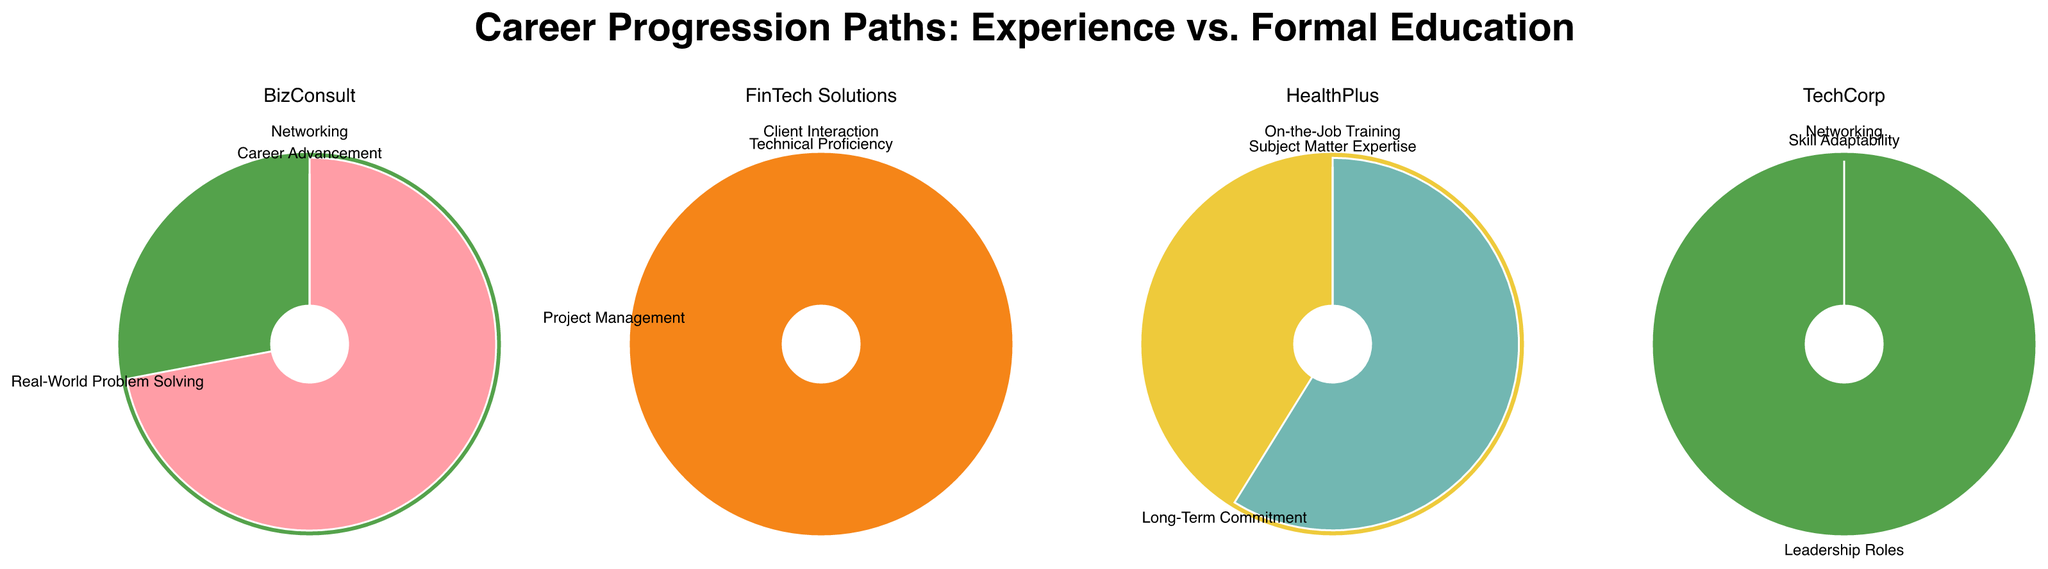What metric does TechCorp value the most in terms of experience? Look at the TechCorp subplot and compare the "Experience" percentage for each metric. "Networking" has the highest value of 90%.
Answer: Networking Which company places the highest value on experience in "Networking"? Compare the "Experience" percentage for "Networking" across all companies. BizConsult values it the most with 95%.
Answer: BizConsult What's the average "Experience" percentage for all metrics in FinTech Solutions? Add the "Experience" percentages for FinTech Solutions (70, 80, 83) and divide by the number of metrics (3). The calculation is (70 + 80 + 83) / 3 = 77.67.
Answer: 77.67 Which metrics in HealthPlus have an "Experience" percentage higher than 80%? HealthPlus has three metrics; check which ones have an "Experience" value above 80%. "On-the-Job Training" (92%) and "Long-Term Commitment" (85%) meet the criteria.
Answer: On-the-Job Training, Long-Term Commitment Between "Technical Proficiency" and "Project Management" in FinTech Solutions, which one has a higher value for formal education? Compare the "Formal Education" values for these two metrics. "Technical Proficiency" has 30% while "Project Management" has 20%.
Answer: Technical Proficiency Which company overall places the least importance on formal education? Assess the average "Formal Education" percentages for all metrics by company:
- TechCorp: (15+10+20)/3 = 15
- BizConsult: (5+12+30)/3 = 15.67
- HealthPlus: (8+15+25)/3 = 16
- FinTech Solutions: (30+20+17)/3 = 22.33
TechCorp averages the lowest with 15%.
Answer: TechCorp Is there a metric where experience outweighs formal education in every company? Review each subplot for each metric and check if the "Experience" value is greater than the "Formal Education" value in every instance.
"Networking", "Project Management", and "Client Interaction" are such metrics as they satisfy the condition across all companies.
Answer: Networking, Project Management, Client Interaction What is the second most valued metric by experience in BizConsult? Sort the metrics by their "Experience" percentages in BizConsult: Networking (95%), Real-World Problem Solving (88%), Career Advancement (70%). The second most valued is "Real-World Problem Solving" at 88%.
Answer: Real-World Problem Solving In HealthPlus, which metric has the highest formal-education percentage? In HealthPlus, compare the "Formal Education" percentages: On-the-Job Training (8%), Long-Term Commitment (15%), Subject Matter Expertise (25%). "Subject Matter Expertise" has the highest at 25%.
Answer: Subject Matter Expertise 